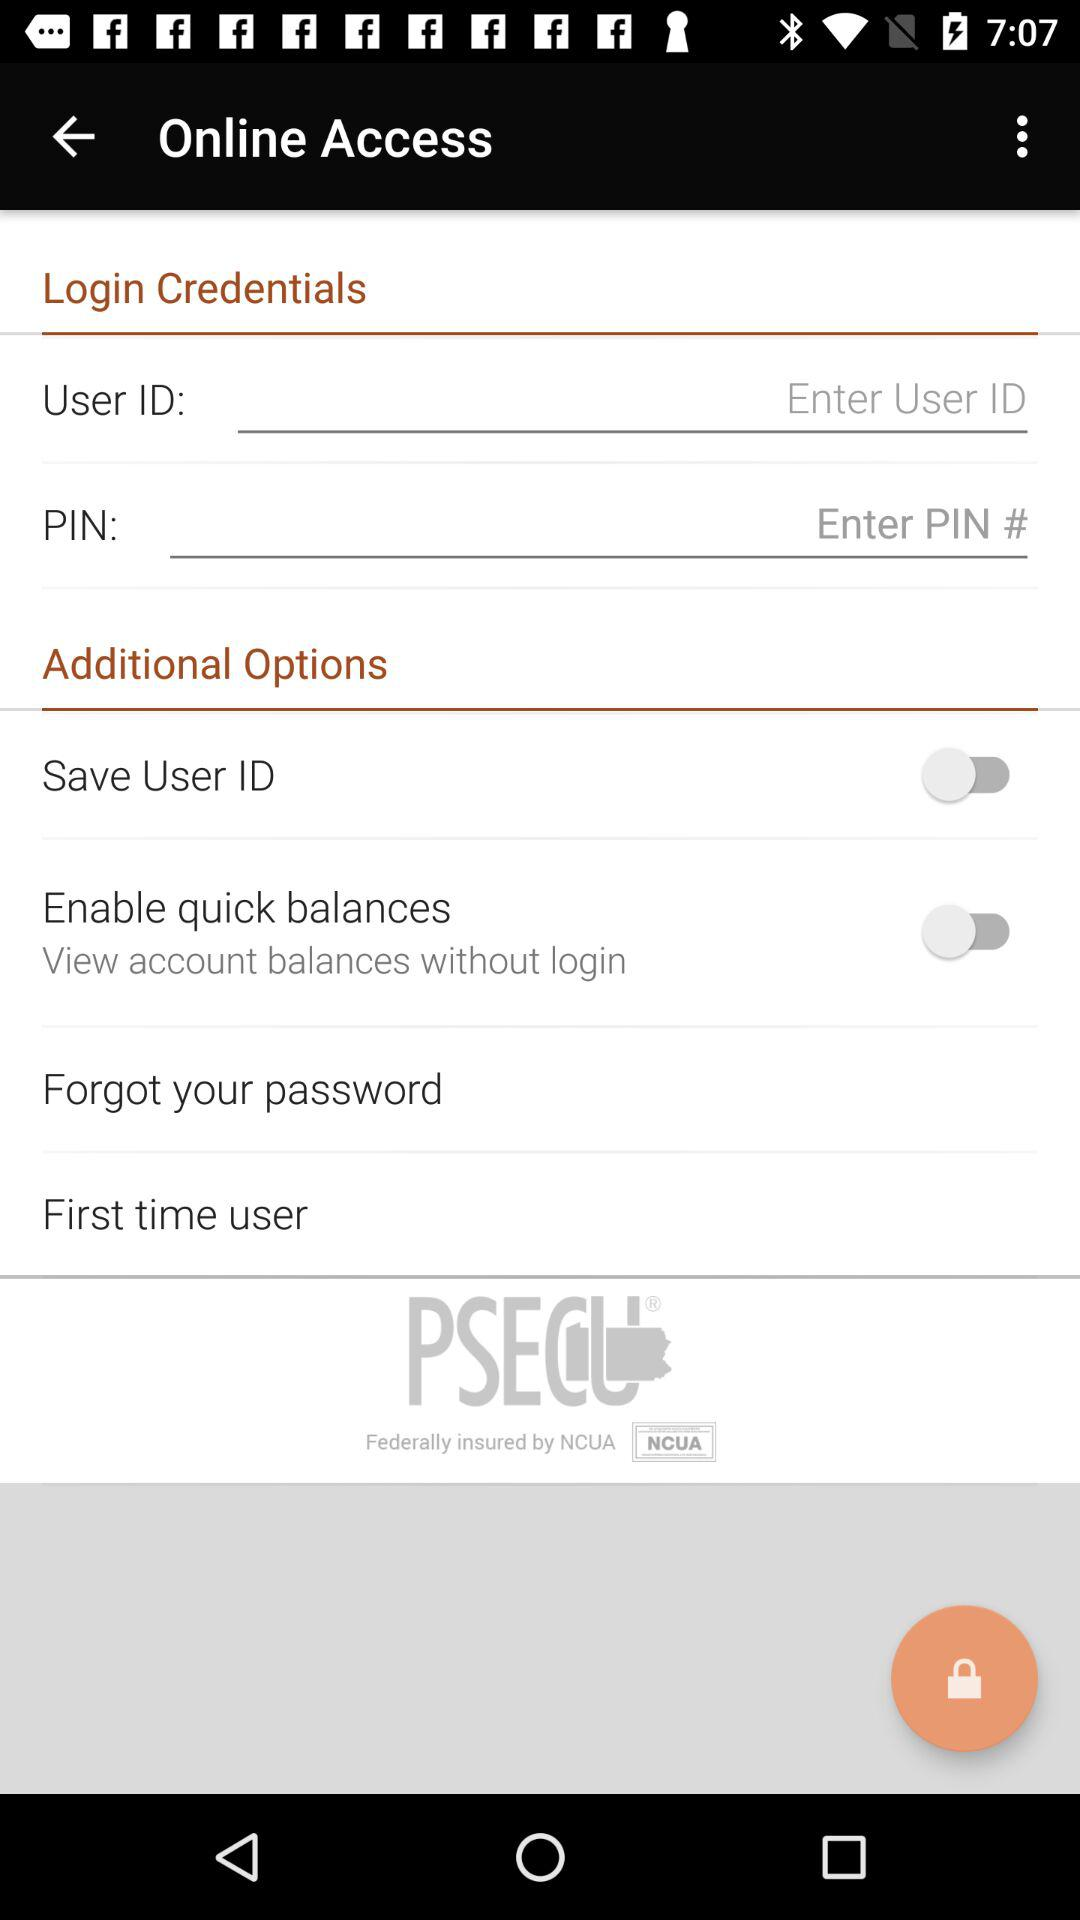How many text input fields are there on this screen?
Answer the question using a single word or phrase. 2 